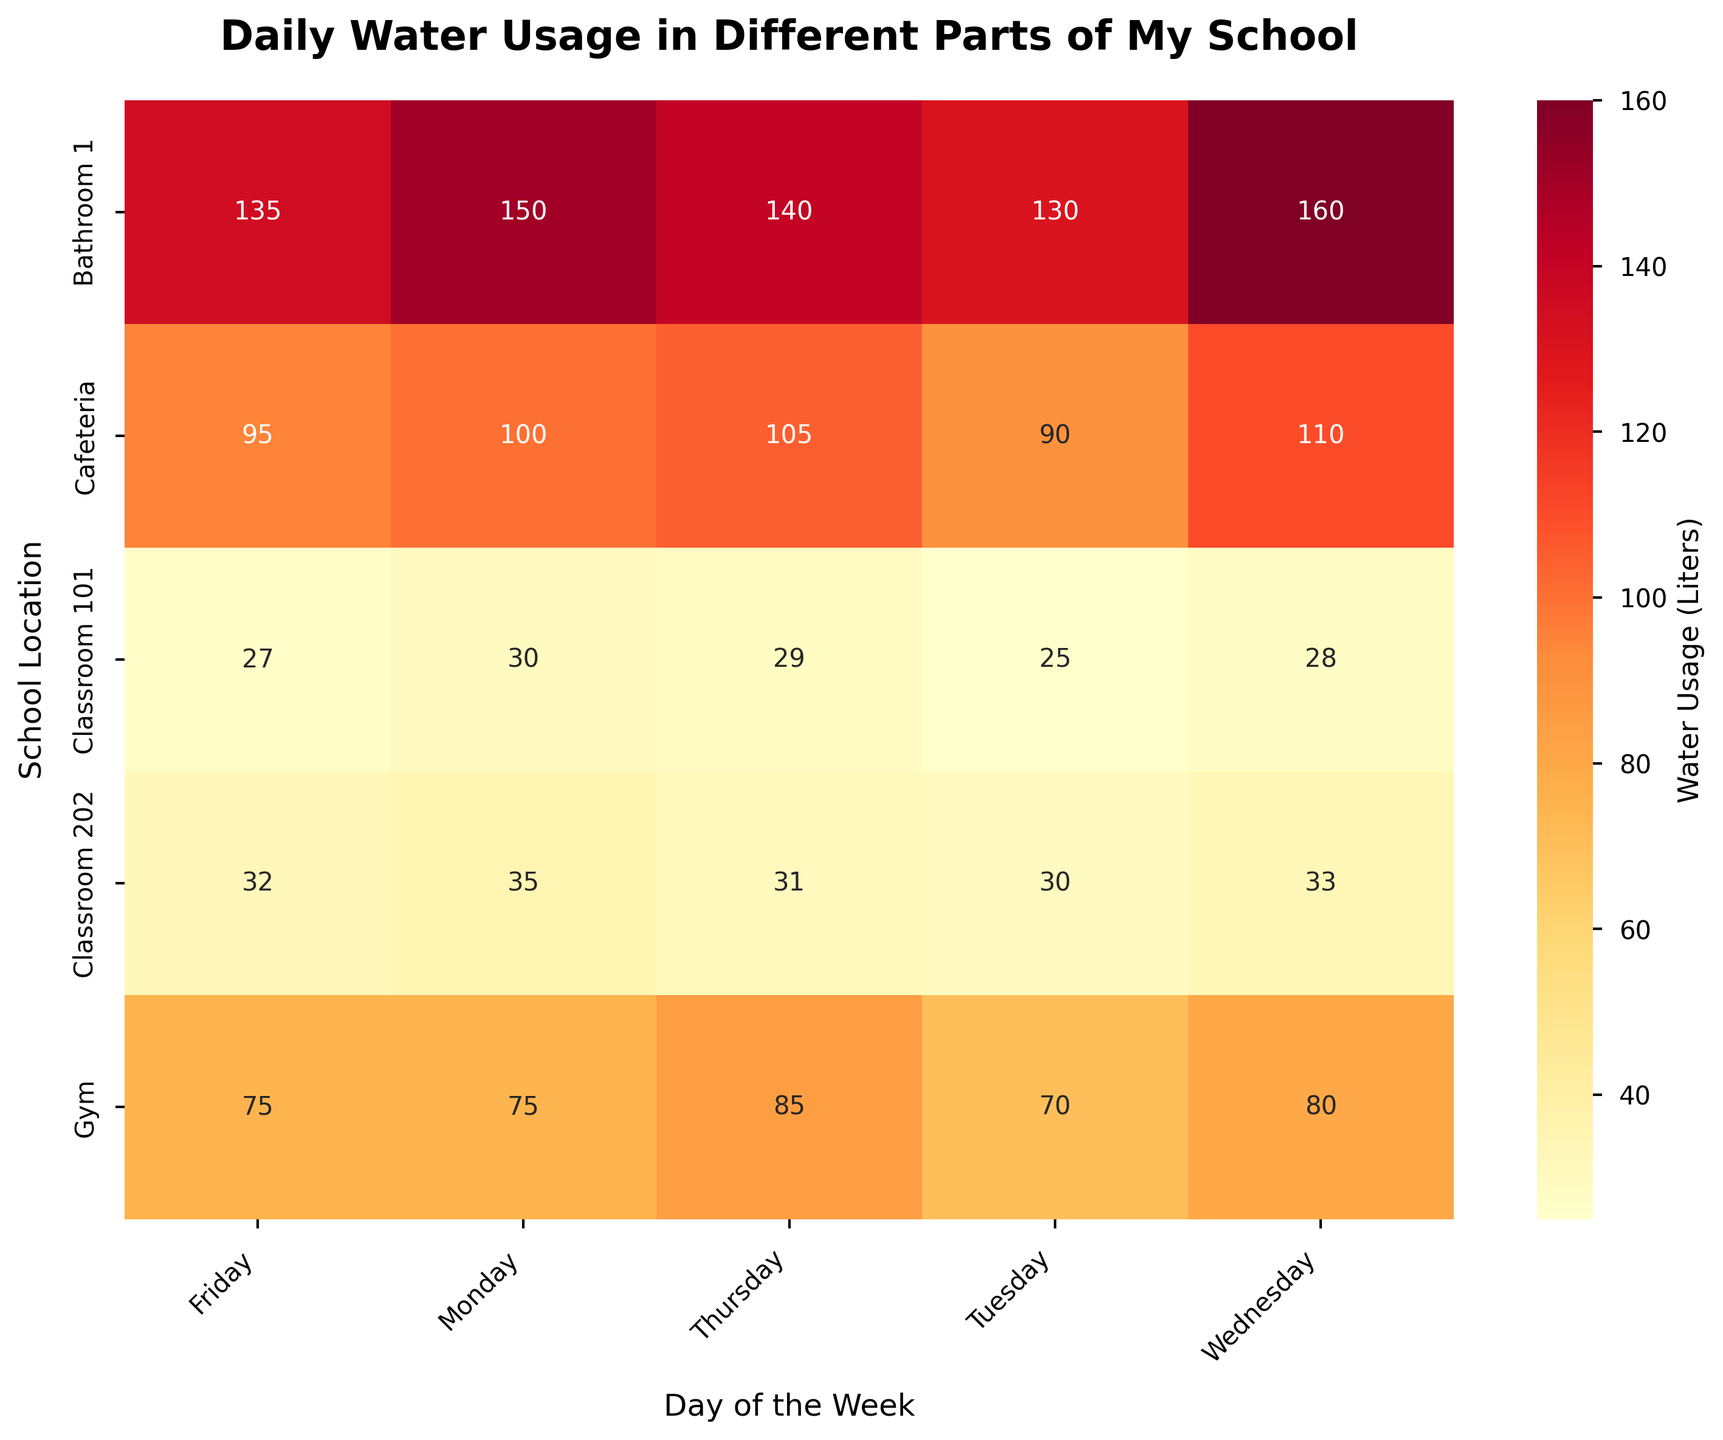What's the title of the figure? The title is displayed at the top of the figure. It summarizes the data shown in the heatmap.
Answer: Daily Water Usage in Different Parts of My School In which location was the highest water usage recorded on Monday? Look at the column for Monday and find the highest value. The highest value is in the row for Bathroom 1.
Answer: Bathroom 1 What's the total water usage in the Cafeteria over the week? Add up the water usage values for the Cafeteria for each day of the week: 100 + 90 + 110 + 105 + 95 = 500.
Answer: 500 Liters Which location used more water on Wednesday, Classroom 101 or Classroom 202? Compare the values for Wednesday in rows for Classroom 101 and Classroom 202. Classroom 202 used 33 liters, and Classroom 101 used 28 liters.
Answer: Classroom 202 On which day did Classroom 101 have the lowest water usage? Look across the row for Classroom 101 and identify the smallest value. The smallest value is 25 liters on Tuesday.
Answer: Tuesday How much more water did the Gym use on Thursday compared to Tuesday? Compare the values for the Gym on Tuesday and Thursday: 85 (Thursday) - 70 (Tuesday) = 15 liters.
Answer: 15 Liters What is the average water usage in Bathroom 1 throughout the week? Calculate the average by adding the values for each day and dividing by the number of days: (150 + 130 + 160 + 140 + 135) / 5 = 715 / 5 = 143.
Answer: 143 Liters Which location had the most consistent water usage, looking at the range of values over the week? Find the range (difference between maximum and minimum values) for each location and identify the smallest range. Classroom 101 ranges from 25 to 30 (range of 5), which is the smallest range.
Answer: Classroom 101 Is there a pattern in water usage trends in the Cafeteria throughout the week? Observe the values for the Cafeteria over the days and note any inclinations or declines. The water usage starts high on Monday (100 liters), decreases on Tuesday (90 liters), then increases again midweek with the highest on Wednesday (110 liters), and decreases slightly towards Friday.
Answer: Mixed pattern 